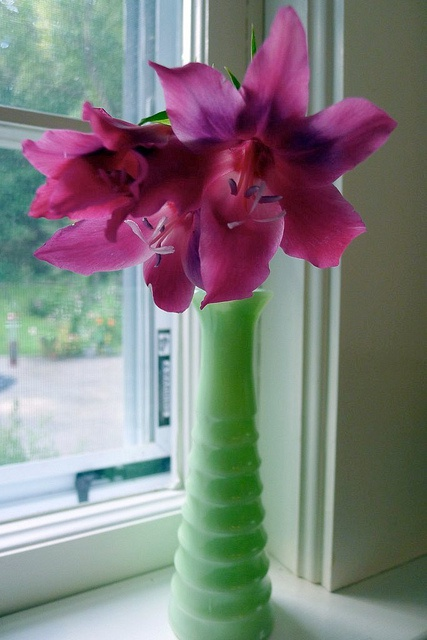Describe the objects in this image and their specific colors. I can see a vase in lightblue, darkgreen, green, and turquoise tones in this image. 